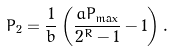Convert formula to latex. <formula><loc_0><loc_0><loc_500><loc_500>P _ { 2 } = \frac { 1 } { b } \left ( \frac { a P _ { \max } } { 2 ^ { R } - 1 } - 1 \right ) .</formula> 